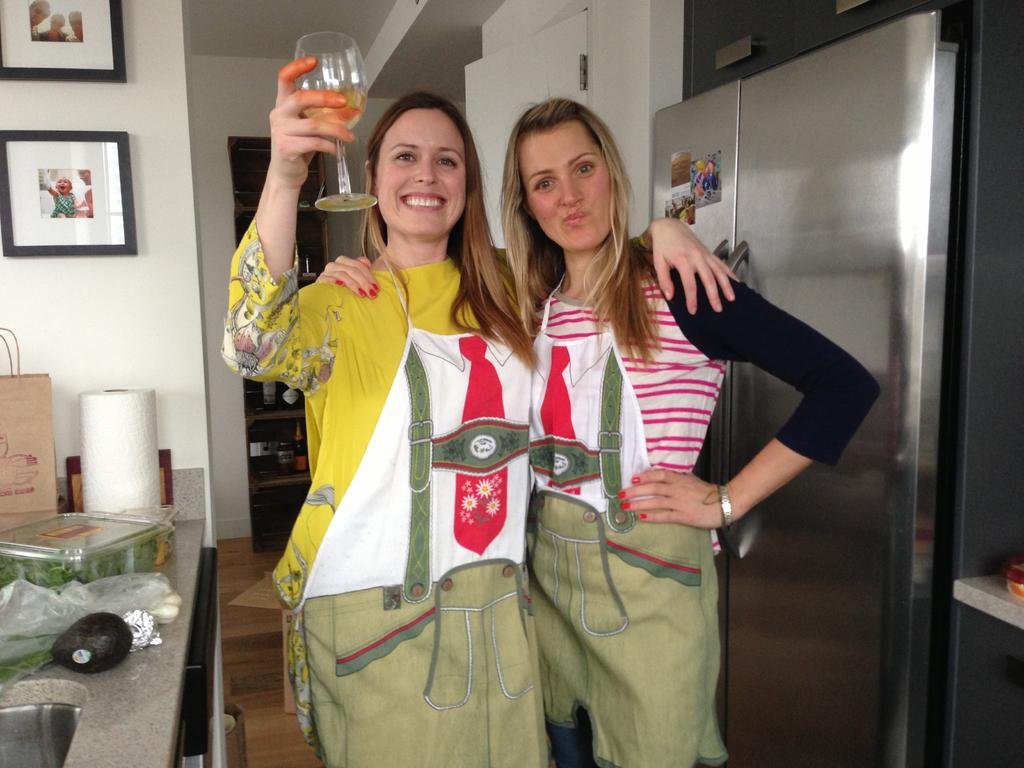How many women are in the image? There are two women in the image. What are the women doing in the image? Both women are standing and smiling. What is one of the women holding in the image? One woman is holding a glass with her hand. What can be seen in the background of the image? There is a refrigerator, frames, a bag, and some unspecified objects in the background of the image. What type of drum can be heard in the background of the image? There is no drum or sound present in the image; it is a still photograph. What type of beef is being prepared in the image? There is no beef or cooking activity depicted in the image. 